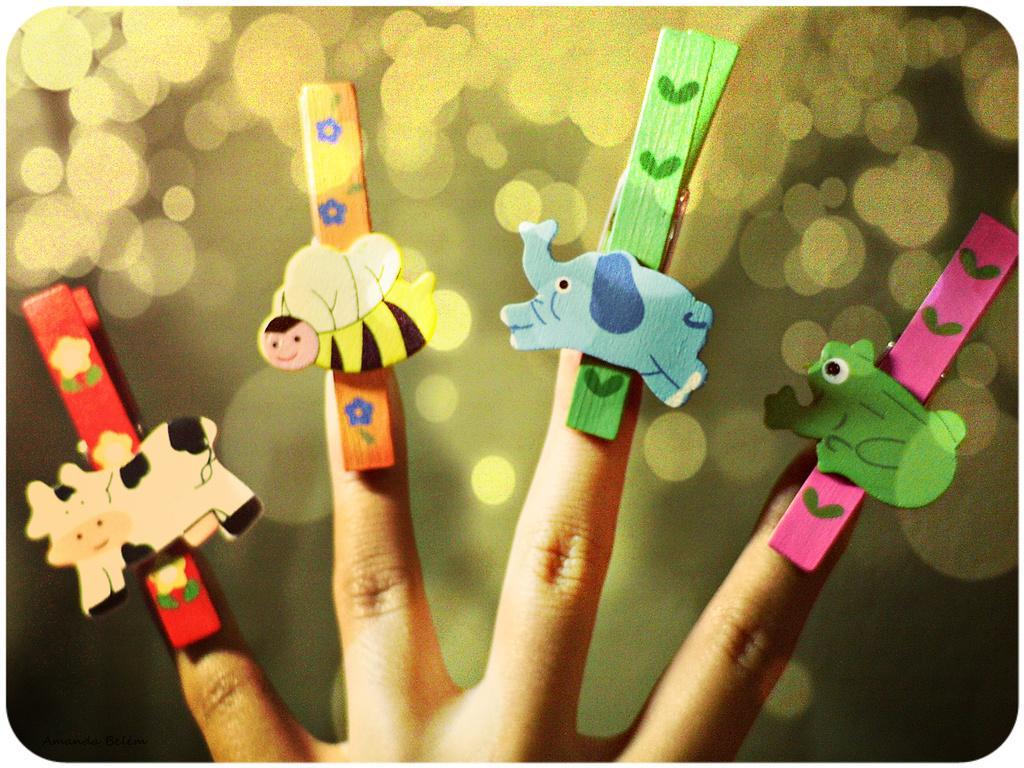Describe this image in one or two sentences. In the image there are fingers of a person and there are some objects attached to the fingers. 